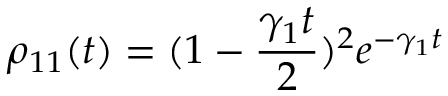Convert formula to latex. <formula><loc_0><loc_0><loc_500><loc_500>\rho _ { 1 1 } ( t ) = ( 1 - \frac { \gamma _ { 1 } t } { 2 } ) ^ { 2 } e ^ { - \gamma _ { 1 } t }</formula> 